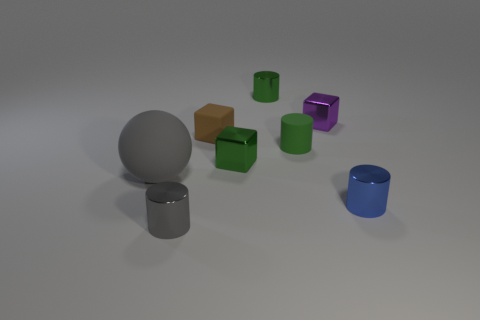Is there anything else that is the same size as the gray matte sphere?
Make the answer very short. No. Are there any other things that have the same color as the small rubber block?
Give a very brief answer. No. There is a big matte sphere; does it have the same color as the tiny block behind the small brown cube?
Your response must be concise. No. What number of things are either small cylinders that are in front of the gray rubber sphere or green metallic things behind the big gray matte ball?
Ensure brevity in your answer.  4. The tiny metal cylinder that is both right of the brown rubber cube and in front of the matte block is what color?
Your answer should be compact. Blue. Are there more tiny purple blocks than metal objects?
Provide a short and direct response. No. Is the shape of the small green metal object left of the tiny green metal cylinder the same as  the brown object?
Give a very brief answer. Yes. How many rubber things are either tiny gray cylinders or small purple blocks?
Your answer should be compact. 0. Is there a small green thing that has the same material as the small gray cylinder?
Offer a terse response. Yes. What material is the small blue cylinder?
Your answer should be very brief. Metal. 